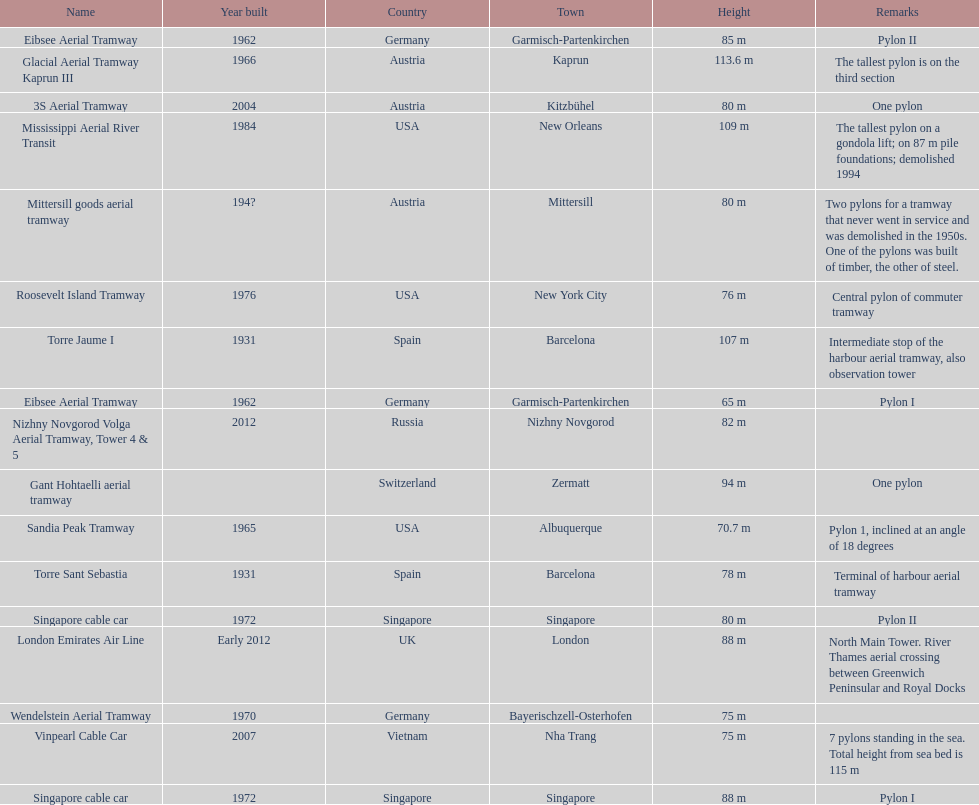Could you parse the entire table? {'header': ['Name', 'Year built', 'Country', 'Town', 'Height', 'Remarks'], 'rows': [['Eibsee Aerial Tramway', '1962', 'Germany', 'Garmisch-Partenkirchen', '85 m', 'Pylon II'], ['Glacial Aerial Tramway Kaprun III', '1966', 'Austria', 'Kaprun', '113.6 m', 'The tallest pylon is on the third section'], ['3S Aerial Tramway', '2004', 'Austria', 'Kitzbühel', '80 m', 'One pylon'], ['Mississippi Aerial River Transit', '1984', 'USA', 'New Orleans', '109 m', 'The tallest pylon on a gondola lift; on 87 m pile foundations; demolished 1994'], ['Mittersill goods aerial tramway', '194?', 'Austria', 'Mittersill', '80 m', 'Two pylons for a tramway that never went in service and was demolished in the 1950s. One of the pylons was built of timber, the other of steel.'], ['Roosevelt Island Tramway', '1976', 'USA', 'New York City', '76 m', 'Central pylon of commuter tramway'], ['Torre Jaume I', '1931', 'Spain', 'Barcelona', '107 m', 'Intermediate stop of the harbour aerial tramway, also observation tower'], ['Eibsee Aerial Tramway', '1962', 'Germany', 'Garmisch-Partenkirchen', '65 m', 'Pylon I'], ['Nizhny Novgorod Volga Aerial Tramway, Tower 4 & 5', '2012', 'Russia', 'Nizhny Novgorod', '82 m', ''], ['Gant Hohtaelli aerial tramway', '', 'Switzerland', 'Zermatt', '94 m', 'One pylon'], ['Sandia Peak Tramway', '1965', 'USA', 'Albuquerque', '70.7 m', 'Pylon 1, inclined at an angle of 18 degrees'], ['Torre Sant Sebastia', '1931', 'Spain', 'Barcelona', '78 m', 'Terminal of harbour aerial tramway'], ['Singapore cable car', '1972', 'Singapore', 'Singapore', '80 m', 'Pylon II'], ['London Emirates Air Line', 'Early 2012', 'UK', 'London', '88 m', 'North Main Tower. River Thames aerial crossing between Greenwich Peninsular and Royal Docks'], ['Wendelstein Aerial Tramway', '1970', 'Germany', 'Bayerischzell-Osterhofen', '75 m', ''], ['Vinpearl Cable Car', '2007', 'Vietnam', 'Nha Trang', '75 m', '7 pylons standing in the sea. Total height from sea bed is 115 m'], ['Singapore cable car', '1972', 'Singapore', 'Singapore', '88 m', 'Pylon I']]} How many pylons are at least 80 meters tall? 11. 